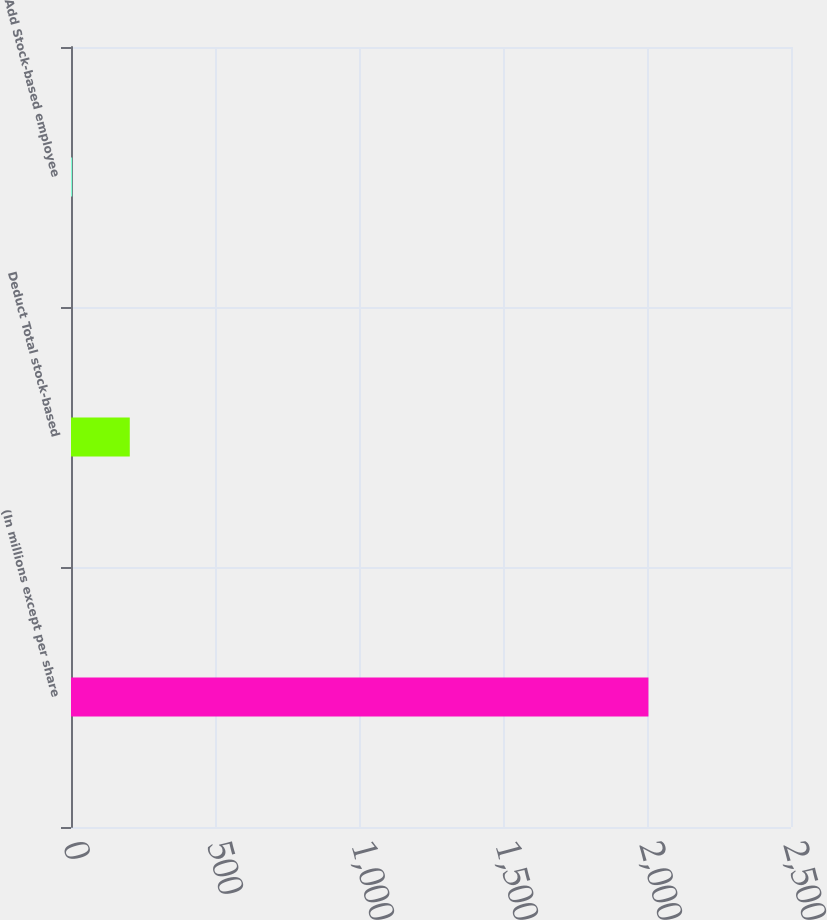Convert chart to OTSL. <chart><loc_0><loc_0><loc_500><loc_500><bar_chart><fcel>(In millions except per share<fcel>Deduct Total stock-based<fcel>Add Stock-based employee<nl><fcel>2005<fcel>204.1<fcel>4<nl></chart> 